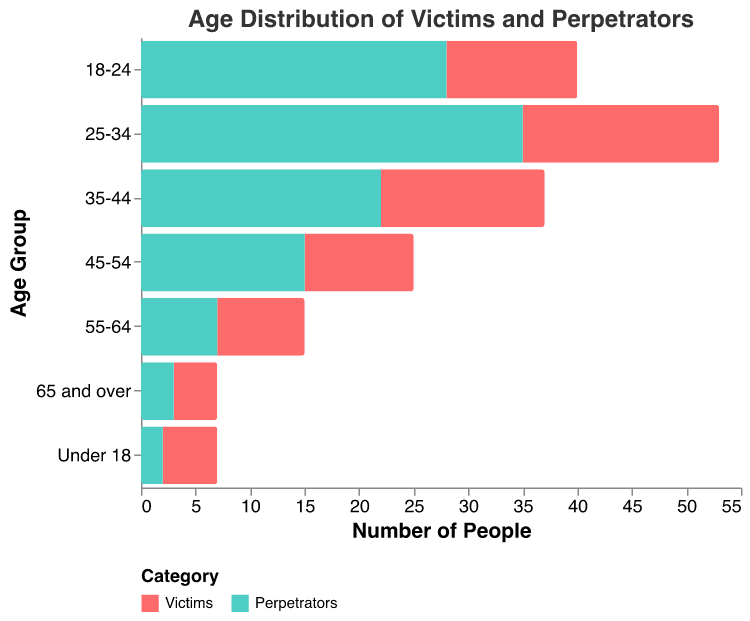What is the title of the figure? The title is typically positioned at the top of the figure and usually summarizes the content of the chart. In this case, it specifies the type of data being visualized.
Answer: Age Distribution of Victims and Perpetrators What are the two categories shown in the figure? The categories can be identified by checking the legend, which is usually positioned at the bottom or the side of the chart. In this case, two categories are specified to differentiate victims from perpetrators.
Answer: Victims and Perpetrators Which age group has the highest number of perpetrators? Each bar represents an age group, and their lengths correspond to the number of people. Comparing these lengths identifies the group with the highest value. The age group 25-34 has the longest bar for perpetrators.
Answer: 25-34 What is the difference in the number of victims and perpetrators in the age group 18-24? The number of victims and perpetrators for each age group can be found by looking at the corresponding bars. The perpetrator value (28) minus the victim value (-12, counting as positive for magnitude) gives the difference.
Answer: 40 Which age group has almost equal numbers of victims and perpetrators? Checking the bars for each age group helps to find which age groups have similar lengths for both victims and perpetrators. The 65 and over age group shows a close number (4 victims, 3 perpetrators).
Answer: 65 and over What is the combined number of victims in the age groups under 18 and 65 and over? Adding the values for victims in both specified age groups (-5 for under 18 and -4 for 65 and over) gives the result.
Answer: 9 How many more perpetrators are there in the age group 45-54 compared to 35-44? Subtracting the number of perpetrators in the 35-44 age group (22) from those in 45-54 (15) yields the difference. It shows fewer perpetrators in the older group.
Answer: 7 fewer Which age group has the lowest number of victims? By comparing the lengths of the bars representing victims, the age group with the shortest bar is identified as having the lowest number. The 65 and over age group has the fewest victims.
Answer: 65 and over What is the range of values for perpetrators across all age groups? Identifying the min (2 for under 18) and max values (35 for 25-34) for perpetrators and calculating the range gives the result.
Answer: 33 For which age group is the difference between the numbers of victims and perpetrators the smallest? By calculating the absolute difference for each age group, the smallest difference is identified. The age group 65 and over has a difference of 1 (4 victims, 3 perpetrators).
Answer: 65 and over 